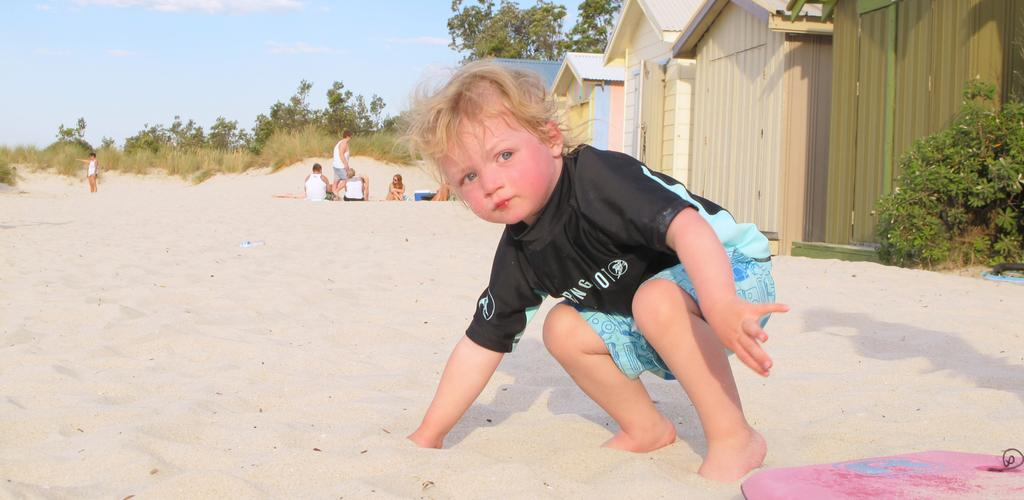What is the main subject in the foreground of the image? There is a small boy in the foreground of the image. What surface is the boy on? The boy is on the sand. What can be seen in the background of the image? There are people, plants, houses, trees, and the sky visible in the background of the image. What type of worm can be seen crawling on the boy's arm in the image? There is no worm present in the image; the boy is on the sand with no visible creatures on his arm. 